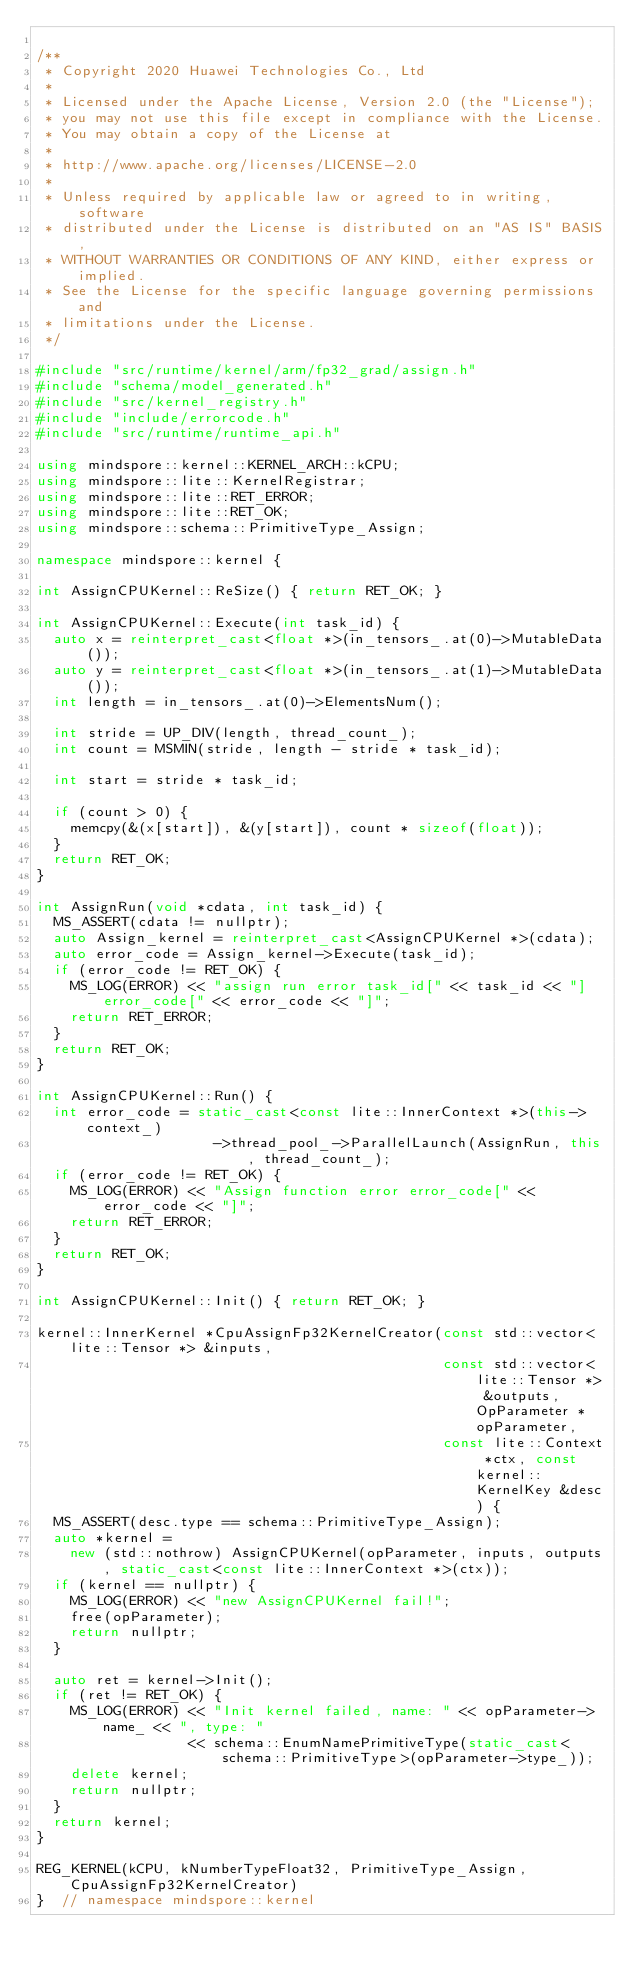Convert code to text. <code><loc_0><loc_0><loc_500><loc_500><_C++_>
/**
 * Copyright 2020 Huawei Technologies Co., Ltd
 *
 * Licensed under the Apache License, Version 2.0 (the "License");
 * you may not use this file except in compliance with the License.
 * You may obtain a copy of the License at
 *
 * http://www.apache.org/licenses/LICENSE-2.0
 *
 * Unless required by applicable law or agreed to in writing, software
 * distributed under the License is distributed on an "AS IS" BASIS,
 * WITHOUT WARRANTIES OR CONDITIONS OF ANY KIND, either express or implied.
 * See the License for the specific language governing permissions and
 * limitations under the License.
 */

#include "src/runtime/kernel/arm/fp32_grad/assign.h"
#include "schema/model_generated.h"
#include "src/kernel_registry.h"
#include "include/errorcode.h"
#include "src/runtime/runtime_api.h"

using mindspore::kernel::KERNEL_ARCH::kCPU;
using mindspore::lite::KernelRegistrar;
using mindspore::lite::RET_ERROR;
using mindspore::lite::RET_OK;
using mindspore::schema::PrimitiveType_Assign;

namespace mindspore::kernel {

int AssignCPUKernel::ReSize() { return RET_OK; }

int AssignCPUKernel::Execute(int task_id) {
  auto x = reinterpret_cast<float *>(in_tensors_.at(0)->MutableData());
  auto y = reinterpret_cast<float *>(in_tensors_.at(1)->MutableData());
  int length = in_tensors_.at(0)->ElementsNum();

  int stride = UP_DIV(length, thread_count_);
  int count = MSMIN(stride, length - stride * task_id);

  int start = stride * task_id;

  if (count > 0) {
    memcpy(&(x[start]), &(y[start]), count * sizeof(float));
  }
  return RET_OK;
}

int AssignRun(void *cdata, int task_id) {
  MS_ASSERT(cdata != nullptr);
  auto Assign_kernel = reinterpret_cast<AssignCPUKernel *>(cdata);
  auto error_code = Assign_kernel->Execute(task_id);
  if (error_code != RET_OK) {
    MS_LOG(ERROR) << "assign run error task_id[" << task_id << "] error_code[" << error_code << "]";
    return RET_ERROR;
  }
  return RET_OK;
}

int AssignCPUKernel::Run() {
  int error_code = static_cast<const lite::InnerContext *>(this->context_)
                     ->thread_pool_->ParallelLaunch(AssignRun, this, thread_count_);
  if (error_code != RET_OK) {
    MS_LOG(ERROR) << "Assign function error error_code[" << error_code << "]";
    return RET_ERROR;
  }
  return RET_OK;
}

int AssignCPUKernel::Init() { return RET_OK; }

kernel::InnerKernel *CpuAssignFp32KernelCreator(const std::vector<lite::Tensor *> &inputs,
                                                const std::vector<lite::Tensor *> &outputs, OpParameter *opParameter,
                                                const lite::Context *ctx, const kernel::KernelKey &desc) {
  MS_ASSERT(desc.type == schema::PrimitiveType_Assign);
  auto *kernel =
    new (std::nothrow) AssignCPUKernel(opParameter, inputs, outputs, static_cast<const lite::InnerContext *>(ctx));
  if (kernel == nullptr) {
    MS_LOG(ERROR) << "new AssignCPUKernel fail!";
    free(opParameter);
    return nullptr;
  }

  auto ret = kernel->Init();
  if (ret != RET_OK) {
    MS_LOG(ERROR) << "Init kernel failed, name: " << opParameter->name_ << ", type: "
                  << schema::EnumNamePrimitiveType(static_cast<schema::PrimitiveType>(opParameter->type_));
    delete kernel;
    return nullptr;
  }
  return kernel;
}

REG_KERNEL(kCPU, kNumberTypeFloat32, PrimitiveType_Assign, CpuAssignFp32KernelCreator)
}  // namespace mindspore::kernel
</code> 